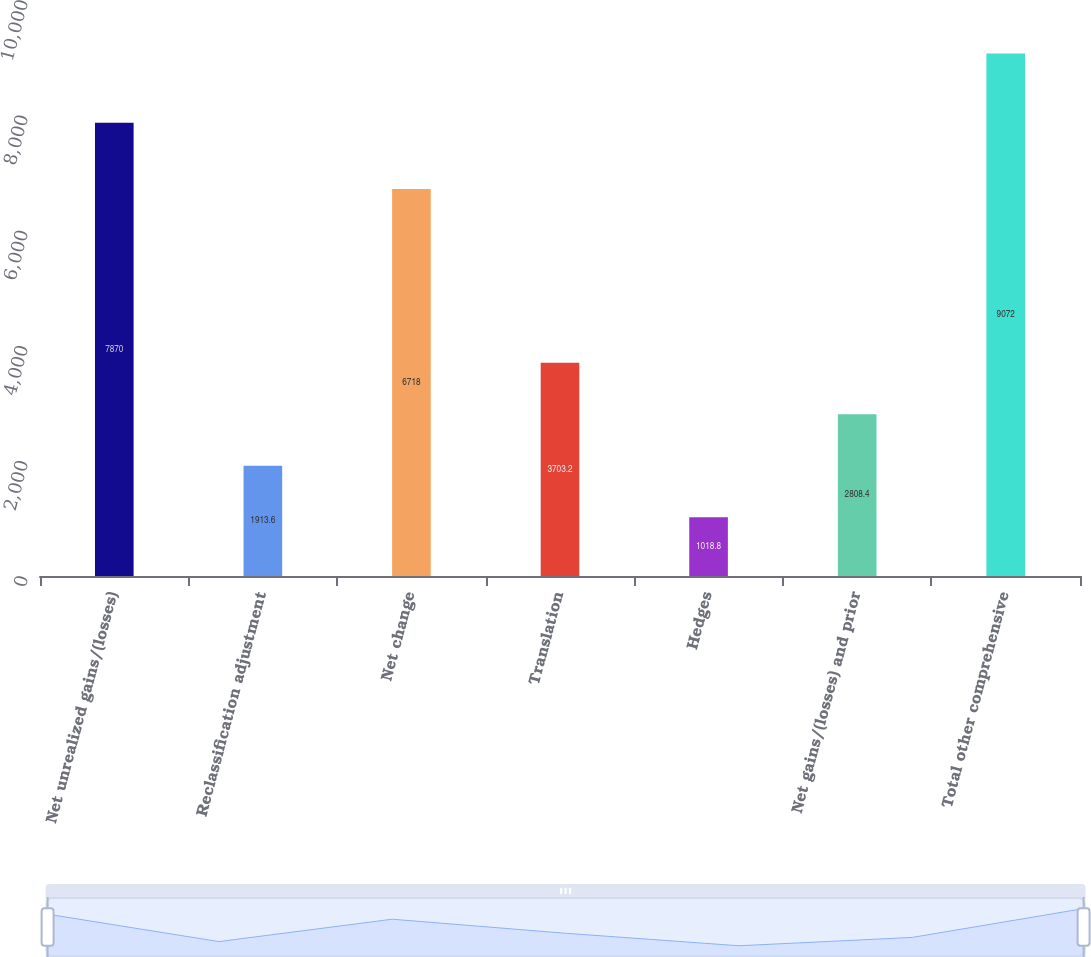<chart> <loc_0><loc_0><loc_500><loc_500><bar_chart><fcel>Net unrealized gains/(losses)<fcel>Reclassification adjustment<fcel>Net change<fcel>Translation<fcel>Hedges<fcel>Net gains/(losses) and prior<fcel>Total other comprehensive<nl><fcel>7870<fcel>1913.6<fcel>6718<fcel>3703.2<fcel>1018.8<fcel>2808.4<fcel>9072<nl></chart> 